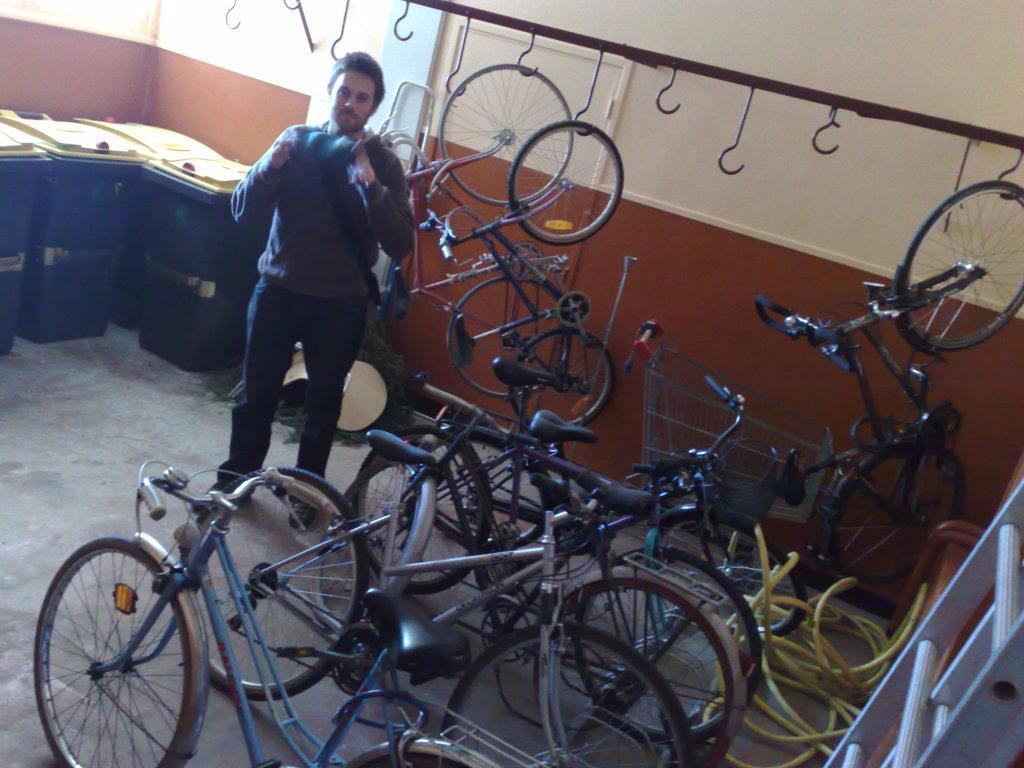In one or two sentences, can you explain what this image depicts? In this image we can see a man standing and there are many bicycles placed in a row. In the background we can see bicycles on the stand. On the left there are bins. In the background there is a wall. 